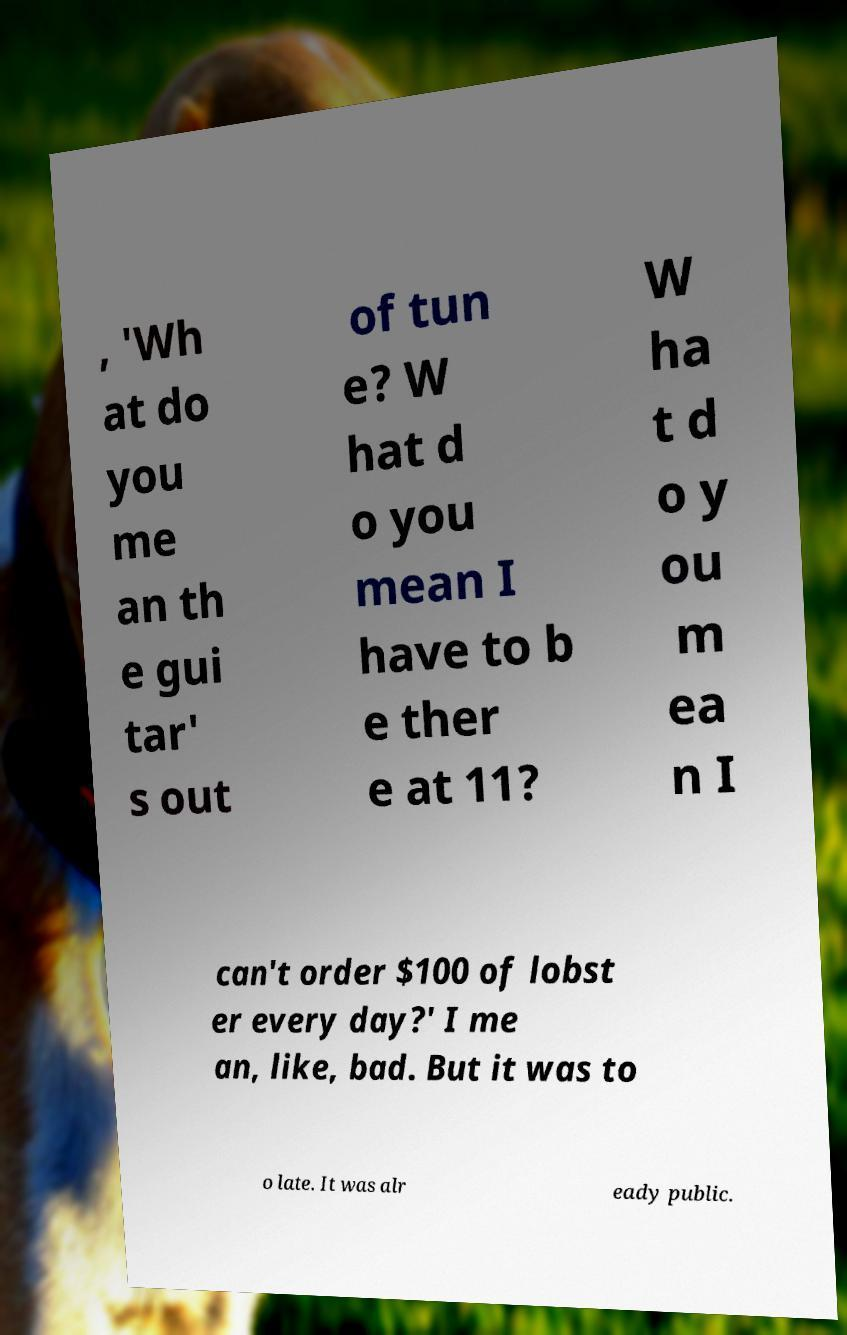For documentation purposes, I need the text within this image transcribed. Could you provide that? , 'Wh at do you me an th e gui tar' s out of tun e? W hat d o you mean I have to b e ther e at 11? W ha t d o y ou m ea n I can't order $100 of lobst er every day?' I me an, like, bad. But it was to o late. It was alr eady public. 